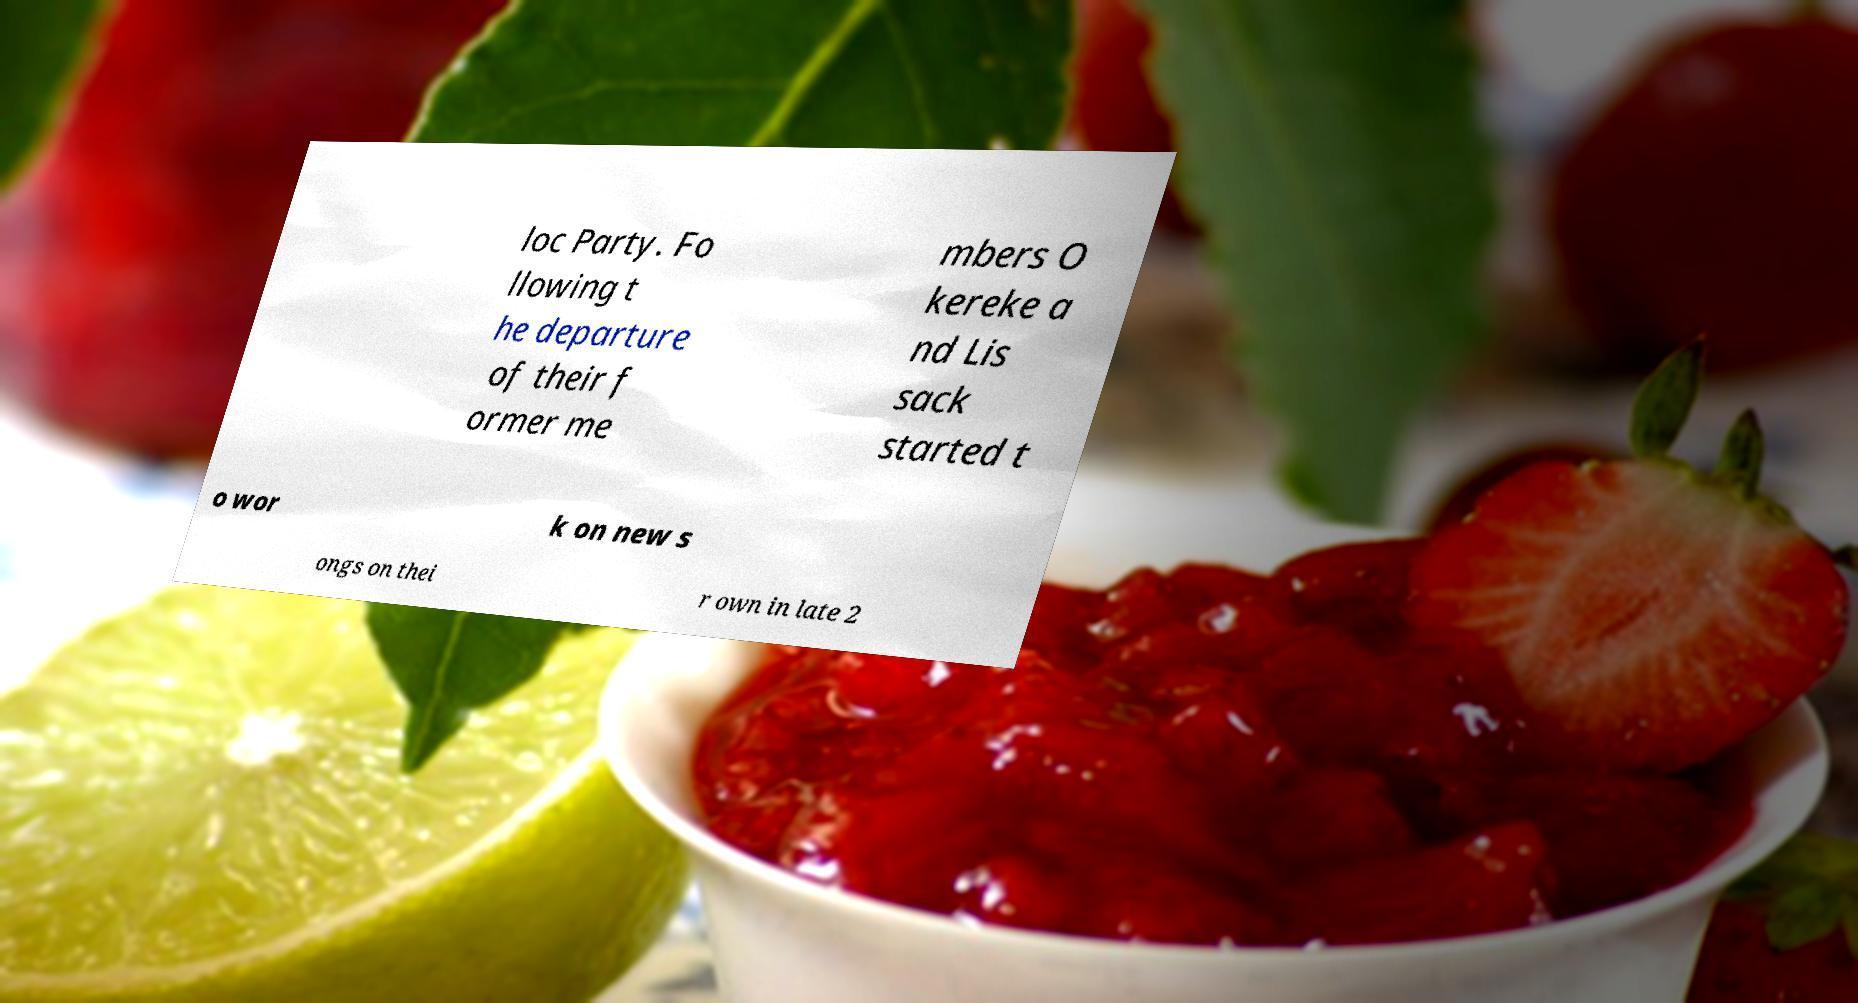I need the written content from this picture converted into text. Can you do that? loc Party. Fo llowing t he departure of their f ormer me mbers O kereke a nd Lis sack started t o wor k on new s ongs on thei r own in late 2 